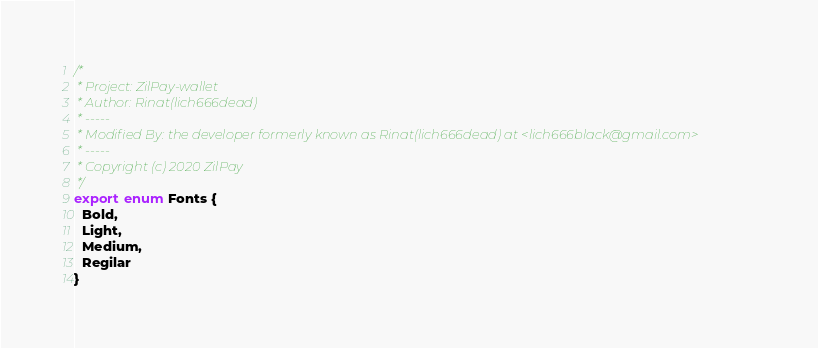<code> <loc_0><loc_0><loc_500><loc_500><_TypeScript_>/*
 * Project: ZilPay-wallet
 * Author: Rinat(lich666dead)
 * -----
 * Modified By: the developer formerly known as Rinat(lich666dead) at <lich666black@gmail.com>
 * -----
 * Copyright (c) 2020 ZilPay
 */
export enum Fonts {
  Bold,
  Light,
  Medium,
  Regilar
}
</code> 